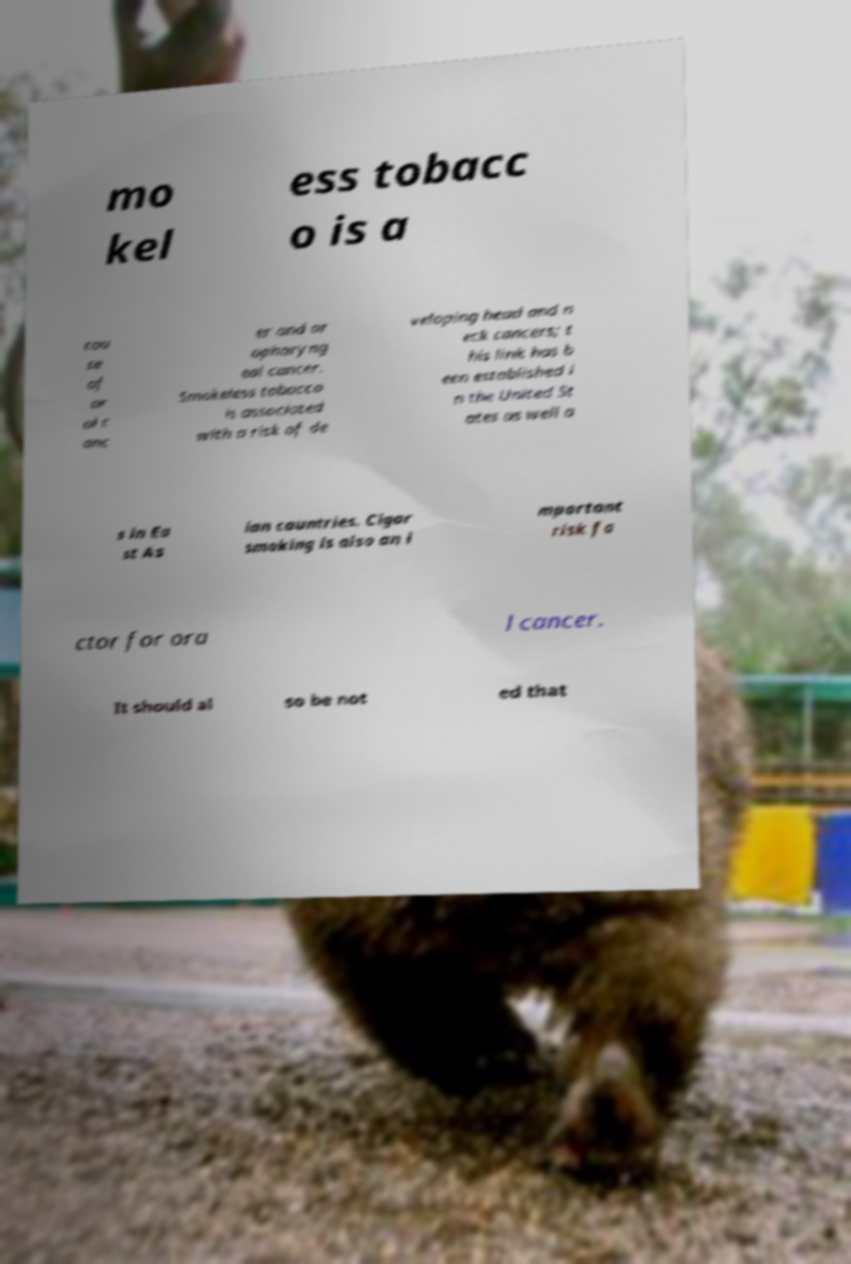Can you read and provide the text displayed in the image?This photo seems to have some interesting text. Can you extract and type it out for me? mo kel ess tobacc o is a cau se of or al c anc er and or opharyng eal cancer. Smokeless tobacco is associated with a risk of de veloping head and n eck cancers; t his link has b een established i n the United St ates as well a s in Ea st As ian countries. Cigar smoking is also an i mportant risk fa ctor for ora l cancer. It should al so be not ed that 